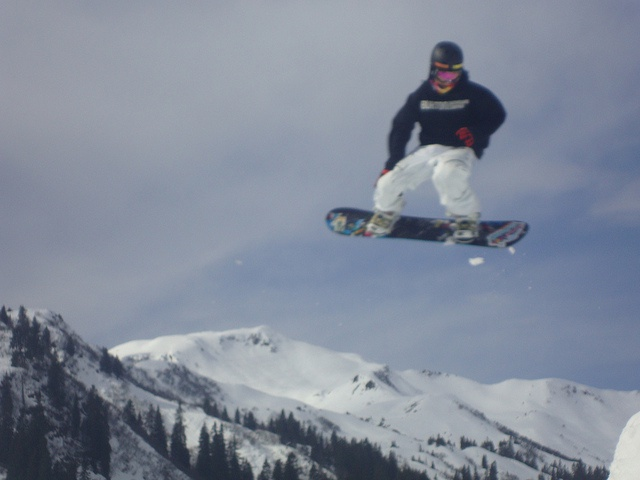Describe the objects in this image and their specific colors. I can see people in darkgray, black, and gray tones and snowboard in darkgray, black, gray, and blue tones in this image. 